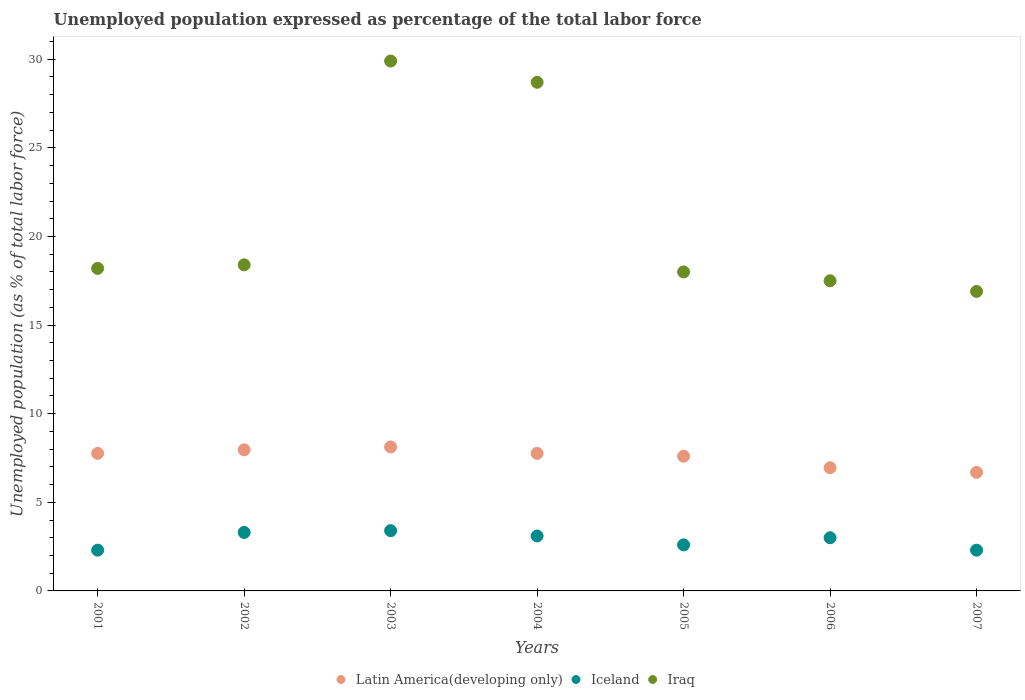Is the number of dotlines equal to the number of legend labels?
Provide a succinct answer. Yes. What is the unemployment in in Iraq in 2004?
Your answer should be very brief. 28.7. Across all years, what is the maximum unemployment in in Iceland?
Make the answer very short. 3.4. Across all years, what is the minimum unemployment in in Iceland?
Your response must be concise. 2.3. What is the total unemployment in in Iraq in the graph?
Provide a succinct answer. 147.6. What is the difference between the unemployment in in Iceland in 2003 and that in 2005?
Offer a terse response. 0.8. What is the difference between the unemployment in in Iceland in 2006 and the unemployment in in Latin America(developing only) in 2005?
Offer a very short reply. -4.6. What is the average unemployment in in Iceland per year?
Your answer should be compact. 2.86. In the year 2007, what is the difference between the unemployment in in Latin America(developing only) and unemployment in in Iceland?
Your answer should be very brief. 4.39. What is the ratio of the unemployment in in Iceland in 2001 to that in 2005?
Provide a succinct answer. 0.88. What is the difference between the highest and the second highest unemployment in in Iraq?
Provide a short and direct response. 1.2. What is the difference between the highest and the lowest unemployment in in Latin America(developing only)?
Offer a terse response. 1.44. Is the sum of the unemployment in in Iraq in 2001 and 2007 greater than the maximum unemployment in in Iceland across all years?
Your response must be concise. Yes. Is the unemployment in in Iraq strictly less than the unemployment in in Latin America(developing only) over the years?
Your response must be concise. No. How many dotlines are there?
Your response must be concise. 3. What is the difference between two consecutive major ticks on the Y-axis?
Your answer should be compact. 5. Does the graph contain any zero values?
Offer a very short reply. No. Where does the legend appear in the graph?
Offer a very short reply. Bottom center. How many legend labels are there?
Provide a short and direct response. 3. How are the legend labels stacked?
Make the answer very short. Horizontal. What is the title of the graph?
Offer a terse response. Unemployed population expressed as percentage of the total labor force. Does "Czech Republic" appear as one of the legend labels in the graph?
Make the answer very short. No. What is the label or title of the X-axis?
Ensure brevity in your answer.  Years. What is the label or title of the Y-axis?
Your response must be concise. Unemployed population (as % of total labor force). What is the Unemployed population (as % of total labor force) of Latin America(developing only) in 2001?
Your answer should be very brief. 7.76. What is the Unemployed population (as % of total labor force) of Iceland in 2001?
Offer a terse response. 2.3. What is the Unemployed population (as % of total labor force) in Iraq in 2001?
Your response must be concise. 18.2. What is the Unemployed population (as % of total labor force) in Latin America(developing only) in 2002?
Provide a short and direct response. 7.96. What is the Unemployed population (as % of total labor force) of Iceland in 2002?
Offer a terse response. 3.3. What is the Unemployed population (as % of total labor force) in Iraq in 2002?
Offer a very short reply. 18.4. What is the Unemployed population (as % of total labor force) in Latin America(developing only) in 2003?
Keep it short and to the point. 8.12. What is the Unemployed population (as % of total labor force) of Iceland in 2003?
Your answer should be compact. 3.4. What is the Unemployed population (as % of total labor force) of Iraq in 2003?
Offer a very short reply. 29.9. What is the Unemployed population (as % of total labor force) in Latin America(developing only) in 2004?
Offer a terse response. 7.76. What is the Unemployed population (as % of total labor force) of Iceland in 2004?
Provide a succinct answer. 3.1. What is the Unemployed population (as % of total labor force) in Iraq in 2004?
Make the answer very short. 28.7. What is the Unemployed population (as % of total labor force) in Latin America(developing only) in 2005?
Your response must be concise. 7.6. What is the Unemployed population (as % of total labor force) in Iceland in 2005?
Your response must be concise. 2.6. What is the Unemployed population (as % of total labor force) of Iraq in 2005?
Provide a short and direct response. 18. What is the Unemployed population (as % of total labor force) of Latin America(developing only) in 2006?
Your answer should be compact. 6.95. What is the Unemployed population (as % of total labor force) of Latin America(developing only) in 2007?
Your answer should be compact. 6.69. What is the Unemployed population (as % of total labor force) in Iceland in 2007?
Your answer should be very brief. 2.3. What is the Unemployed population (as % of total labor force) of Iraq in 2007?
Provide a succinct answer. 16.9. Across all years, what is the maximum Unemployed population (as % of total labor force) in Latin America(developing only)?
Offer a very short reply. 8.12. Across all years, what is the maximum Unemployed population (as % of total labor force) in Iceland?
Make the answer very short. 3.4. Across all years, what is the maximum Unemployed population (as % of total labor force) in Iraq?
Offer a terse response. 29.9. Across all years, what is the minimum Unemployed population (as % of total labor force) in Latin America(developing only)?
Make the answer very short. 6.69. Across all years, what is the minimum Unemployed population (as % of total labor force) in Iceland?
Your response must be concise. 2.3. Across all years, what is the minimum Unemployed population (as % of total labor force) of Iraq?
Keep it short and to the point. 16.9. What is the total Unemployed population (as % of total labor force) in Latin America(developing only) in the graph?
Offer a terse response. 52.85. What is the total Unemployed population (as % of total labor force) of Iraq in the graph?
Give a very brief answer. 147.6. What is the difference between the Unemployed population (as % of total labor force) in Latin America(developing only) in 2001 and that in 2002?
Your response must be concise. -0.2. What is the difference between the Unemployed population (as % of total labor force) in Iceland in 2001 and that in 2002?
Offer a very short reply. -1. What is the difference between the Unemployed population (as % of total labor force) of Iraq in 2001 and that in 2002?
Offer a very short reply. -0.2. What is the difference between the Unemployed population (as % of total labor force) of Latin America(developing only) in 2001 and that in 2003?
Provide a succinct answer. -0.36. What is the difference between the Unemployed population (as % of total labor force) of Latin America(developing only) in 2001 and that in 2004?
Provide a short and direct response. -0. What is the difference between the Unemployed population (as % of total labor force) in Iraq in 2001 and that in 2004?
Make the answer very short. -10.5. What is the difference between the Unemployed population (as % of total labor force) in Latin America(developing only) in 2001 and that in 2005?
Give a very brief answer. 0.16. What is the difference between the Unemployed population (as % of total labor force) in Iceland in 2001 and that in 2005?
Provide a short and direct response. -0.3. What is the difference between the Unemployed population (as % of total labor force) of Iraq in 2001 and that in 2005?
Provide a short and direct response. 0.2. What is the difference between the Unemployed population (as % of total labor force) in Latin America(developing only) in 2001 and that in 2006?
Your answer should be very brief. 0.81. What is the difference between the Unemployed population (as % of total labor force) of Iraq in 2001 and that in 2006?
Give a very brief answer. 0.7. What is the difference between the Unemployed population (as % of total labor force) of Latin America(developing only) in 2001 and that in 2007?
Provide a succinct answer. 1.07. What is the difference between the Unemployed population (as % of total labor force) of Iceland in 2001 and that in 2007?
Ensure brevity in your answer.  0. What is the difference between the Unemployed population (as % of total labor force) of Iraq in 2001 and that in 2007?
Provide a short and direct response. 1.3. What is the difference between the Unemployed population (as % of total labor force) in Latin America(developing only) in 2002 and that in 2003?
Keep it short and to the point. -0.16. What is the difference between the Unemployed population (as % of total labor force) in Iraq in 2002 and that in 2003?
Provide a short and direct response. -11.5. What is the difference between the Unemployed population (as % of total labor force) of Latin America(developing only) in 2002 and that in 2004?
Offer a very short reply. 0.2. What is the difference between the Unemployed population (as % of total labor force) of Latin America(developing only) in 2002 and that in 2005?
Offer a terse response. 0.36. What is the difference between the Unemployed population (as % of total labor force) in Latin America(developing only) in 2002 and that in 2006?
Offer a very short reply. 1.01. What is the difference between the Unemployed population (as % of total labor force) of Iceland in 2002 and that in 2006?
Keep it short and to the point. 0.3. What is the difference between the Unemployed population (as % of total labor force) in Iraq in 2002 and that in 2006?
Your answer should be very brief. 0.9. What is the difference between the Unemployed population (as % of total labor force) of Latin America(developing only) in 2002 and that in 2007?
Make the answer very short. 1.27. What is the difference between the Unemployed population (as % of total labor force) in Iceland in 2002 and that in 2007?
Provide a short and direct response. 1. What is the difference between the Unemployed population (as % of total labor force) in Latin America(developing only) in 2003 and that in 2004?
Keep it short and to the point. 0.36. What is the difference between the Unemployed population (as % of total labor force) of Iceland in 2003 and that in 2004?
Make the answer very short. 0.3. What is the difference between the Unemployed population (as % of total labor force) in Latin America(developing only) in 2003 and that in 2005?
Ensure brevity in your answer.  0.52. What is the difference between the Unemployed population (as % of total labor force) of Iraq in 2003 and that in 2005?
Your answer should be compact. 11.9. What is the difference between the Unemployed population (as % of total labor force) of Latin America(developing only) in 2003 and that in 2006?
Offer a terse response. 1.17. What is the difference between the Unemployed population (as % of total labor force) in Iceland in 2003 and that in 2006?
Your answer should be compact. 0.4. What is the difference between the Unemployed population (as % of total labor force) of Iraq in 2003 and that in 2006?
Provide a short and direct response. 12.4. What is the difference between the Unemployed population (as % of total labor force) of Latin America(developing only) in 2003 and that in 2007?
Give a very brief answer. 1.44. What is the difference between the Unemployed population (as % of total labor force) in Latin America(developing only) in 2004 and that in 2005?
Your answer should be compact. 0.16. What is the difference between the Unemployed population (as % of total labor force) of Latin America(developing only) in 2004 and that in 2006?
Your answer should be compact. 0.81. What is the difference between the Unemployed population (as % of total labor force) of Iceland in 2004 and that in 2006?
Offer a very short reply. 0.1. What is the difference between the Unemployed population (as % of total labor force) in Latin America(developing only) in 2004 and that in 2007?
Offer a very short reply. 1.07. What is the difference between the Unemployed population (as % of total labor force) of Iceland in 2004 and that in 2007?
Provide a short and direct response. 0.8. What is the difference between the Unemployed population (as % of total labor force) in Latin America(developing only) in 2005 and that in 2006?
Give a very brief answer. 0.65. What is the difference between the Unemployed population (as % of total labor force) of Latin America(developing only) in 2005 and that in 2007?
Give a very brief answer. 0.91. What is the difference between the Unemployed population (as % of total labor force) in Iceland in 2005 and that in 2007?
Ensure brevity in your answer.  0.3. What is the difference between the Unemployed population (as % of total labor force) of Latin America(developing only) in 2006 and that in 2007?
Ensure brevity in your answer.  0.26. What is the difference between the Unemployed population (as % of total labor force) in Iceland in 2006 and that in 2007?
Make the answer very short. 0.7. What is the difference between the Unemployed population (as % of total labor force) of Iraq in 2006 and that in 2007?
Give a very brief answer. 0.6. What is the difference between the Unemployed population (as % of total labor force) in Latin America(developing only) in 2001 and the Unemployed population (as % of total labor force) in Iceland in 2002?
Ensure brevity in your answer.  4.46. What is the difference between the Unemployed population (as % of total labor force) in Latin America(developing only) in 2001 and the Unemployed population (as % of total labor force) in Iraq in 2002?
Provide a succinct answer. -10.64. What is the difference between the Unemployed population (as % of total labor force) in Iceland in 2001 and the Unemployed population (as % of total labor force) in Iraq in 2002?
Provide a short and direct response. -16.1. What is the difference between the Unemployed population (as % of total labor force) of Latin America(developing only) in 2001 and the Unemployed population (as % of total labor force) of Iceland in 2003?
Your answer should be very brief. 4.36. What is the difference between the Unemployed population (as % of total labor force) in Latin America(developing only) in 2001 and the Unemployed population (as % of total labor force) in Iraq in 2003?
Your response must be concise. -22.14. What is the difference between the Unemployed population (as % of total labor force) of Iceland in 2001 and the Unemployed population (as % of total labor force) of Iraq in 2003?
Provide a succinct answer. -27.6. What is the difference between the Unemployed population (as % of total labor force) in Latin America(developing only) in 2001 and the Unemployed population (as % of total labor force) in Iceland in 2004?
Offer a very short reply. 4.66. What is the difference between the Unemployed population (as % of total labor force) of Latin America(developing only) in 2001 and the Unemployed population (as % of total labor force) of Iraq in 2004?
Your response must be concise. -20.94. What is the difference between the Unemployed population (as % of total labor force) in Iceland in 2001 and the Unemployed population (as % of total labor force) in Iraq in 2004?
Offer a terse response. -26.4. What is the difference between the Unemployed population (as % of total labor force) in Latin America(developing only) in 2001 and the Unemployed population (as % of total labor force) in Iceland in 2005?
Provide a short and direct response. 5.16. What is the difference between the Unemployed population (as % of total labor force) of Latin America(developing only) in 2001 and the Unemployed population (as % of total labor force) of Iraq in 2005?
Your answer should be compact. -10.24. What is the difference between the Unemployed population (as % of total labor force) in Iceland in 2001 and the Unemployed population (as % of total labor force) in Iraq in 2005?
Offer a terse response. -15.7. What is the difference between the Unemployed population (as % of total labor force) in Latin America(developing only) in 2001 and the Unemployed population (as % of total labor force) in Iceland in 2006?
Your answer should be very brief. 4.76. What is the difference between the Unemployed population (as % of total labor force) of Latin America(developing only) in 2001 and the Unemployed population (as % of total labor force) of Iraq in 2006?
Provide a short and direct response. -9.74. What is the difference between the Unemployed population (as % of total labor force) in Iceland in 2001 and the Unemployed population (as % of total labor force) in Iraq in 2006?
Ensure brevity in your answer.  -15.2. What is the difference between the Unemployed population (as % of total labor force) of Latin America(developing only) in 2001 and the Unemployed population (as % of total labor force) of Iceland in 2007?
Keep it short and to the point. 5.46. What is the difference between the Unemployed population (as % of total labor force) in Latin America(developing only) in 2001 and the Unemployed population (as % of total labor force) in Iraq in 2007?
Provide a succinct answer. -9.14. What is the difference between the Unemployed population (as % of total labor force) of Iceland in 2001 and the Unemployed population (as % of total labor force) of Iraq in 2007?
Offer a terse response. -14.6. What is the difference between the Unemployed population (as % of total labor force) in Latin America(developing only) in 2002 and the Unemployed population (as % of total labor force) in Iceland in 2003?
Provide a succinct answer. 4.56. What is the difference between the Unemployed population (as % of total labor force) of Latin America(developing only) in 2002 and the Unemployed population (as % of total labor force) of Iraq in 2003?
Keep it short and to the point. -21.94. What is the difference between the Unemployed population (as % of total labor force) in Iceland in 2002 and the Unemployed population (as % of total labor force) in Iraq in 2003?
Your response must be concise. -26.6. What is the difference between the Unemployed population (as % of total labor force) of Latin America(developing only) in 2002 and the Unemployed population (as % of total labor force) of Iceland in 2004?
Offer a terse response. 4.86. What is the difference between the Unemployed population (as % of total labor force) in Latin America(developing only) in 2002 and the Unemployed population (as % of total labor force) in Iraq in 2004?
Provide a short and direct response. -20.74. What is the difference between the Unemployed population (as % of total labor force) of Iceland in 2002 and the Unemployed population (as % of total labor force) of Iraq in 2004?
Your answer should be very brief. -25.4. What is the difference between the Unemployed population (as % of total labor force) of Latin America(developing only) in 2002 and the Unemployed population (as % of total labor force) of Iceland in 2005?
Offer a very short reply. 5.36. What is the difference between the Unemployed population (as % of total labor force) of Latin America(developing only) in 2002 and the Unemployed population (as % of total labor force) of Iraq in 2005?
Offer a very short reply. -10.04. What is the difference between the Unemployed population (as % of total labor force) of Iceland in 2002 and the Unemployed population (as % of total labor force) of Iraq in 2005?
Offer a terse response. -14.7. What is the difference between the Unemployed population (as % of total labor force) of Latin America(developing only) in 2002 and the Unemployed population (as % of total labor force) of Iceland in 2006?
Your answer should be compact. 4.96. What is the difference between the Unemployed population (as % of total labor force) in Latin America(developing only) in 2002 and the Unemployed population (as % of total labor force) in Iraq in 2006?
Your answer should be compact. -9.54. What is the difference between the Unemployed population (as % of total labor force) of Latin America(developing only) in 2002 and the Unemployed population (as % of total labor force) of Iceland in 2007?
Provide a short and direct response. 5.66. What is the difference between the Unemployed population (as % of total labor force) of Latin America(developing only) in 2002 and the Unemployed population (as % of total labor force) of Iraq in 2007?
Provide a succinct answer. -8.94. What is the difference between the Unemployed population (as % of total labor force) in Latin America(developing only) in 2003 and the Unemployed population (as % of total labor force) in Iceland in 2004?
Provide a short and direct response. 5.02. What is the difference between the Unemployed population (as % of total labor force) in Latin America(developing only) in 2003 and the Unemployed population (as % of total labor force) in Iraq in 2004?
Offer a very short reply. -20.58. What is the difference between the Unemployed population (as % of total labor force) in Iceland in 2003 and the Unemployed population (as % of total labor force) in Iraq in 2004?
Make the answer very short. -25.3. What is the difference between the Unemployed population (as % of total labor force) in Latin America(developing only) in 2003 and the Unemployed population (as % of total labor force) in Iceland in 2005?
Your answer should be compact. 5.52. What is the difference between the Unemployed population (as % of total labor force) in Latin America(developing only) in 2003 and the Unemployed population (as % of total labor force) in Iraq in 2005?
Make the answer very short. -9.88. What is the difference between the Unemployed population (as % of total labor force) in Iceland in 2003 and the Unemployed population (as % of total labor force) in Iraq in 2005?
Make the answer very short. -14.6. What is the difference between the Unemployed population (as % of total labor force) in Latin America(developing only) in 2003 and the Unemployed population (as % of total labor force) in Iceland in 2006?
Your answer should be compact. 5.12. What is the difference between the Unemployed population (as % of total labor force) in Latin America(developing only) in 2003 and the Unemployed population (as % of total labor force) in Iraq in 2006?
Make the answer very short. -9.38. What is the difference between the Unemployed population (as % of total labor force) in Iceland in 2003 and the Unemployed population (as % of total labor force) in Iraq in 2006?
Provide a short and direct response. -14.1. What is the difference between the Unemployed population (as % of total labor force) in Latin America(developing only) in 2003 and the Unemployed population (as % of total labor force) in Iceland in 2007?
Give a very brief answer. 5.82. What is the difference between the Unemployed population (as % of total labor force) of Latin America(developing only) in 2003 and the Unemployed population (as % of total labor force) of Iraq in 2007?
Your answer should be compact. -8.78. What is the difference between the Unemployed population (as % of total labor force) in Iceland in 2003 and the Unemployed population (as % of total labor force) in Iraq in 2007?
Provide a succinct answer. -13.5. What is the difference between the Unemployed population (as % of total labor force) in Latin America(developing only) in 2004 and the Unemployed population (as % of total labor force) in Iceland in 2005?
Provide a short and direct response. 5.16. What is the difference between the Unemployed population (as % of total labor force) in Latin America(developing only) in 2004 and the Unemployed population (as % of total labor force) in Iraq in 2005?
Your answer should be compact. -10.24. What is the difference between the Unemployed population (as % of total labor force) of Iceland in 2004 and the Unemployed population (as % of total labor force) of Iraq in 2005?
Provide a succinct answer. -14.9. What is the difference between the Unemployed population (as % of total labor force) in Latin America(developing only) in 2004 and the Unemployed population (as % of total labor force) in Iceland in 2006?
Your answer should be compact. 4.76. What is the difference between the Unemployed population (as % of total labor force) in Latin America(developing only) in 2004 and the Unemployed population (as % of total labor force) in Iraq in 2006?
Your answer should be compact. -9.74. What is the difference between the Unemployed population (as % of total labor force) of Iceland in 2004 and the Unemployed population (as % of total labor force) of Iraq in 2006?
Ensure brevity in your answer.  -14.4. What is the difference between the Unemployed population (as % of total labor force) of Latin America(developing only) in 2004 and the Unemployed population (as % of total labor force) of Iceland in 2007?
Offer a very short reply. 5.46. What is the difference between the Unemployed population (as % of total labor force) in Latin America(developing only) in 2004 and the Unemployed population (as % of total labor force) in Iraq in 2007?
Provide a succinct answer. -9.14. What is the difference between the Unemployed population (as % of total labor force) of Latin America(developing only) in 2005 and the Unemployed population (as % of total labor force) of Iceland in 2006?
Your answer should be compact. 4.6. What is the difference between the Unemployed population (as % of total labor force) in Latin America(developing only) in 2005 and the Unemployed population (as % of total labor force) in Iraq in 2006?
Make the answer very short. -9.9. What is the difference between the Unemployed population (as % of total labor force) in Iceland in 2005 and the Unemployed population (as % of total labor force) in Iraq in 2006?
Provide a succinct answer. -14.9. What is the difference between the Unemployed population (as % of total labor force) in Latin America(developing only) in 2005 and the Unemployed population (as % of total labor force) in Iceland in 2007?
Your answer should be very brief. 5.3. What is the difference between the Unemployed population (as % of total labor force) of Latin America(developing only) in 2005 and the Unemployed population (as % of total labor force) of Iraq in 2007?
Provide a succinct answer. -9.3. What is the difference between the Unemployed population (as % of total labor force) of Iceland in 2005 and the Unemployed population (as % of total labor force) of Iraq in 2007?
Your answer should be compact. -14.3. What is the difference between the Unemployed population (as % of total labor force) in Latin America(developing only) in 2006 and the Unemployed population (as % of total labor force) in Iceland in 2007?
Offer a terse response. 4.65. What is the difference between the Unemployed population (as % of total labor force) of Latin America(developing only) in 2006 and the Unemployed population (as % of total labor force) of Iraq in 2007?
Your response must be concise. -9.95. What is the difference between the Unemployed population (as % of total labor force) in Iceland in 2006 and the Unemployed population (as % of total labor force) in Iraq in 2007?
Your answer should be very brief. -13.9. What is the average Unemployed population (as % of total labor force) in Latin America(developing only) per year?
Provide a succinct answer. 7.55. What is the average Unemployed population (as % of total labor force) of Iceland per year?
Your response must be concise. 2.86. What is the average Unemployed population (as % of total labor force) in Iraq per year?
Keep it short and to the point. 21.09. In the year 2001, what is the difference between the Unemployed population (as % of total labor force) of Latin America(developing only) and Unemployed population (as % of total labor force) of Iceland?
Offer a very short reply. 5.46. In the year 2001, what is the difference between the Unemployed population (as % of total labor force) of Latin America(developing only) and Unemployed population (as % of total labor force) of Iraq?
Provide a short and direct response. -10.44. In the year 2001, what is the difference between the Unemployed population (as % of total labor force) of Iceland and Unemployed population (as % of total labor force) of Iraq?
Offer a very short reply. -15.9. In the year 2002, what is the difference between the Unemployed population (as % of total labor force) of Latin America(developing only) and Unemployed population (as % of total labor force) of Iceland?
Make the answer very short. 4.66. In the year 2002, what is the difference between the Unemployed population (as % of total labor force) in Latin America(developing only) and Unemployed population (as % of total labor force) in Iraq?
Provide a short and direct response. -10.44. In the year 2002, what is the difference between the Unemployed population (as % of total labor force) of Iceland and Unemployed population (as % of total labor force) of Iraq?
Offer a terse response. -15.1. In the year 2003, what is the difference between the Unemployed population (as % of total labor force) in Latin America(developing only) and Unemployed population (as % of total labor force) in Iceland?
Your answer should be compact. 4.72. In the year 2003, what is the difference between the Unemployed population (as % of total labor force) in Latin America(developing only) and Unemployed population (as % of total labor force) in Iraq?
Offer a very short reply. -21.78. In the year 2003, what is the difference between the Unemployed population (as % of total labor force) of Iceland and Unemployed population (as % of total labor force) of Iraq?
Ensure brevity in your answer.  -26.5. In the year 2004, what is the difference between the Unemployed population (as % of total labor force) in Latin America(developing only) and Unemployed population (as % of total labor force) in Iceland?
Your response must be concise. 4.66. In the year 2004, what is the difference between the Unemployed population (as % of total labor force) in Latin America(developing only) and Unemployed population (as % of total labor force) in Iraq?
Your answer should be compact. -20.94. In the year 2004, what is the difference between the Unemployed population (as % of total labor force) of Iceland and Unemployed population (as % of total labor force) of Iraq?
Give a very brief answer. -25.6. In the year 2005, what is the difference between the Unemployed population (as % of total labor force) in Latin America(developing only) and Unemployed population (as % of total labor force) in Iceland?
Ensure brevity in your answer.  5. In the year 2005, what is the difference between the Unemployed population (as % of total labor force) of Latin America(developing only) and Unemployed population (as % of total labor force) of Iraq?
Make the answer very short. -10.4. In the year 2005, what is the difference between the Unemployed population (as % of total labor force) in Iceland and Unemployed population (as % of total labor force) in Iraq?
Your answer should be very brief. -15.4. In the year 2006, what is the difference between the Unemployed population (as % of total labor force) of Latin America(developing only) and Unemployed population (as % of total labor force) of Iceland?
Provide a succinct answer. 3.95. In the year 2006, what is the difference between the Unemployed population (as % of total labor force) of Latin America(developing only) and Unemployed population (as % of total labor force) of Iraq?
Keep it short and to the point. -10.55. In the year 2006, what is the difference between the Unemployed population (as % of total labor force) of Iceland and Unemployed population (as % of total labor force) of Iraq?
Provide a short and direct response. -14.5. In the year 2007, what is the difference between the Unemployed population (as % of total labor force) in Latin America(developing only) and Unemployed population (as % of total labor force) in Iceland?
Offer a terse response. 4.39. In the year 2007, what is the difference between the Unemployed population (as % of total labor force) of Latin America(developing only) and Unemployed population (as % of total labor force) of Iraq?
Provide a short and direct response. -10.21. In the year 2007, what is the difference between the Unemployed population (as % of total labor force) of Iceland and Unemployed population (as % of total labor force) of Iraq?
Your answer should be compact. -14.6. What is the ratio of the Unemployed population (as % of total labor force) of Latin America(developing only) in 2001 to that in 2002?
Provide a short and direct response. 0.97. What is the ratio of the Unemployed population (as % of total labor force) of Iceland in 2001 to that in 2002?
Ensure brevity in your answer.  0.7. What is the ratio of the Unemployed population (as % of total labor force) in Latin America(developing only) in 2001 to that in 2003?
Provide a short and direct response. 0.96. What is the ratio of the Unemployed population (as % of total labor force) of Iceland in 2001 to that in 2003?
Give a very brief answer. 0.68. What is the ratio of the Unemployed population (as % of total labor force) of Iraq in 2001 to that in 2003?
Your answer should be very brief. 0.61. What is the ratio of the Unemployed population (as % of total labor force) in Latin America(developing only) in 2001 to that in 2004?
Provide a succinct answer. 1. What is the ratio of the Unemployed population (as % of total labor force) in Iceland in 2001 to that in 2004?
Your answer should be compact. 0.74. What is the ratio of the Unemployed population (as % of total labor force) in Iraq in 2001 to that in 2004?
Your response must be concise. 0.63. What is the ratio of the Unemployed population (as % of total labor force) in Latin America(developing only) in 2001 to that in 2005?
Keep it short and to the point. 1.02. What is the ratio of the Unemployed population (as % of total labor force) of Iceland in 2001 to that in 2005?
Offer a terse response. 0.88. What is the ratio of the Unemployed population (as % of total labor force) of Iraq in 2001 to that in 2005?
Provide a short and direct response. 1.01. What is the ratio of the Unemployed population (as % of total labor force) in Latin America(developing only) in 2001 to that in 2006?
Keep it short and to the point. 1.12. What is the ratio of the Unemployed population (as % of total labor force) of Iceland in 2001 to that in 2006?
Provide a short and direct response. 0.77. What is the ratio of the Unemployed population (as % of total labor force) of Iraq in 2001 to that in 2006?
Your answer should be very brief. 1.04. What is the ratio of the Unemployed population (as % of total labor force) in Latin America(developing only) in 2001 to that in 2007?
Your response must be concise. 1.16. What is the ratio of the Unemployed population (as % of total labor force) of Iraq in 2001 to that in 2007?
Make the answer very short. 1.08. What is the ratio of the Unemployed population (as % of total labor force) of Latin America(developing only) in 2002 to that in 2003?
Your answer should be very brief. 0.98. What is the ratio of the Unemployed population (as % of total labor force) in Iceland in 2002 to that in 2003?
Offer a very short reply. 0.97. What is the ratio of the Unemployed population (as % of total labor force) in Iraq in 2002 to that in 2003?
Provide a succinct answer. 0.62. What is the ratio of the Unemployed population (as % of total labor force) of Latin America(developing only) in 2002 to that in 2004?
Your response must be concise. 1.03. What is the ratio of the Unemployed population (as % of total labor force) of Iceland in 2002 to that in 2004?
Offer a terse response. 1.06. What is the ratio of the Unemployed population (as % of total labor force) in Iraq in 2002 to that in 2004?
Your answer should be compact. 0.64. What is the ratio of the Unemployed population (as % of total labor force) of Latin America(developing only) in 2002 to that in 2005?
Provide a succinct answer. 1.05. What is the ratio of the Unemployed population (as % of total labor force) of Iceland in 2002 to that in 2005?
Keep it short and to the point. 1.27. What is the ratio of the Unemployed population (as % of total labor force) of Iraq in 2002 to that in 2005?
Provide a short and direct response. 1.02. What is the ratio of the Unemployed population (as % of total labor force) in Latin America(developing only) in 2002 to that in 2006?
Offer a terse response. 1.15. What is the ratio of the Unemployed population (as % of total labor force) of Iraq in 2002 to that in 2006?
Your response must be concise. 1.05. What is the ratio of the Unemployed population (as % of total labor force) in Latin America(developing only) in 2002 to that in 2007?
Ensure brevity in your answer.  1.19. What is the ratio of the Unemployed population (as % of total labor force) in Iceland in 2002 to that in 2007?
Offer a terse response. 1.43. What is the ratio of the Unemployed population (as % of total labor force) in Iraq in 2002 to that in 2007?
Provide a succinct answer. 1.09. What is the ratio of the Unemployed population (as % of total labor force) of Latin America(developing only) in 2003 to that in 2004?
Keep it short and to the point. 1.05. What is the ratio of the Unemployed population (as % of total labor force) of Iceland in 2003 to that in 2004?
Offer a terse response. 1.1. What is the ratio of the Unemployed population (as % of total labor force) in Iraq in 2003 to that in 2004?
Your answer should be compact. 1.04. What is the ratio of the Unemployed population (as % of total labor force) of Latin America(developing only) in 2003 to that in 2005?
Offer a terse response. 1.07. What is the ratio of the Unemployed population (as % of total labor force) of Iceland in 2003 to that in 2005?
Keep it short and to the point. 1.31. What is the ratio of the Unemployed population (as % of total labor force) of Iraq in 2003 to that in 2005?
Offer a terse response. 1.66. What is the ratio of the Unemployed population (as % of total labor force) of Latin America(developing only) in 2003 to that in 2006?
Give a very brief answer. 1.17. What is the ratio of the Unemployed population (as % of total labor force) of Iceland in 2003 to that in 2006?
Ensure brevity in your answer.  1.13. What is the ratio of the Unemployed population (as % of total labor force) in Iraq in 2003 to that in 2006?
Your answer should be compact. 1.71. What is the ratio of the Unemployed population (as % of total labor force) in Latin America(developing only) in 2003 to that in 2007?
Give a very brief answer. 1.21. What is the ratio of the Unemployed population (as % of total labor force) in Iceland in 2003 to that in 2007?
Offer a terse response. 1.48. What is the ratio of the Unemployed population (as % of total labor force) in Iraq in 2003 to that in 2007?
Offer a terse response. 1.77. What is the ratio of the Unemployed population (as % of total labor force) in Latin America(developing only) in 2004 to that in 2005?
Keep it short and to the point. 1.02. What is the ratio of the Unemployed population (as % of total labor force) in Iceland in 2004 to that in 2005?
Give a very brief answer. 1.19. What is the ratio of the Unemployed population (as % of total labor force) of Iraq in 2004 to that in 2005?
Make the answer very short. 1.59. What is the ratio of the Unemployed population (as % of total labor force) in Latin America(developing only) in 2004 to that in 2006?
Your answer should be very brief. 1.12. What is the ratio of the Unemployed population (as % of total labor force) of Iraq in 2004 to that in 2006?
Offer a terse response. 1.64. What is the ratio of the Unemployed population (as % of total labor force) of Latin America(developing only) in 2004 to that in 2007?
Make the answer very short. 1.16. What is the ratio of the Unemployed population (as % of total labor force) in Iceland in 2004 to that in 2007?
Give a very brief answer. 1.35. What is the ratio of the Unemployed population (as % of total labor force) of Iraq in 2004 to that in 2007?
Your answer should be very brief. 1.7. What is the ratio of the Unemployed population (as % of total labor force) of Latin America(developing only) in 2005 to that in 2006?
Give a very brief answer. 1.09. What is the ratio of the Unemployed population (as % of total labor force) of Iceland in 2005 to that in 2006?
Ensure brevity in your answer.  0.87. What is the ratio of the Unemployed population (as % of total labor force) in Iraq in 2005 to that in 2006?
Provide a succinct answer. 1.03. What is the ratio of the Unemployed population (as % of total labor force) in Latin America(developing only) in 2005 to that in 2007?
Your answer should be compact. 1.14. What is the ratio of the Unemployed population (as % of total labor force) in Iceland in 2005 to that in 2007?
Your answer should be compact. 1.13. What is the ratio of the Unemployed population (as % of total labor force) of Iraq in 2005 to that in 2007?
Provide a succinct answer. 1.07. What is the ratio of the Unemployed population (as % of total labor force) of Latin America(developing only) in 2006 to that in 2007?
Offer a very short reply. 1.04. What is the ratio of the Unemployed population (as % of total labor force) of Iceland in 2006 to that in 2007?
Your response must be concise. 1.3. What is the ratio of the Unemployed population (as % of total labor force) of Iraq in 2006 to that in 2007?
Your response must be concise. 1.04. What is the difference between the highest and the second highest Unemployed population (as % of total labor force) of Latin America(developing only)?
Make the answer very short. 0.16. What is the difference between the highest and the second highest Unemployed population (as % of total labor force) of Iraq?
Offer a very short reply. 1.2. What is the difference between the highest and the lowest Unemployed population (as % of total labor force) of Latin America(developing only)?
Your response must be concise. 1.44. What is the difference between the highest and the lowest Unemployed population (as % of total labor force) of Iceland?
Your response must be concise. 1.1. What is the difference between the highest and the lowest Unemployed population (as % of total labor force) of Iraq?
Your answer should be very brief. 13. 